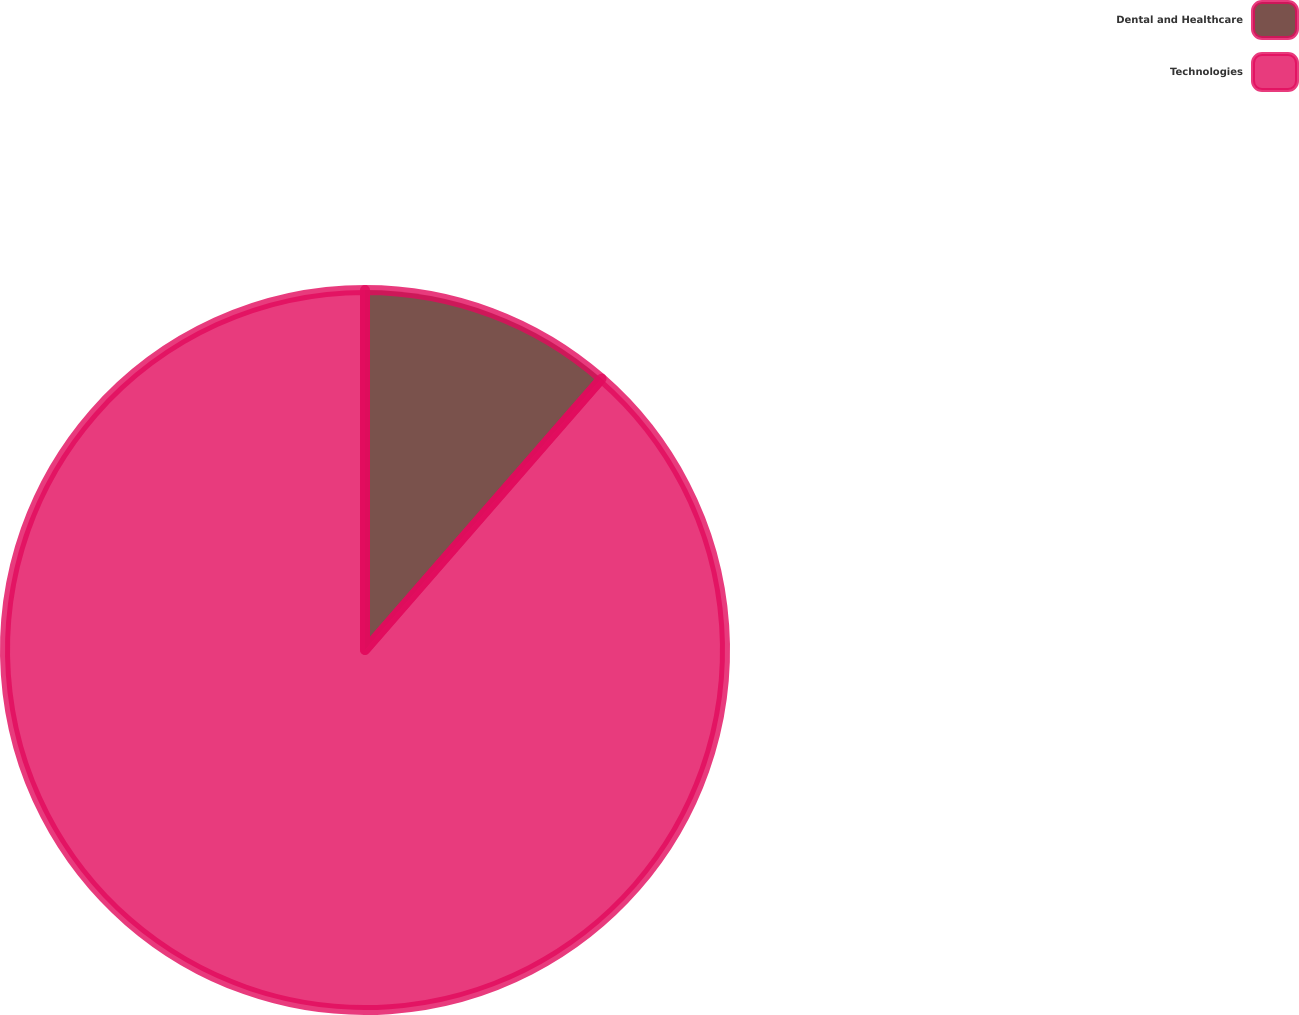Convert chart to OTSL. <chart><loc_0><loc_0><loc_500><loc_500><pie_chart><fcel>Dental and Healthcare<fcel>Technologies<nl><fcel>11.41%<fcel>88.59%<nl></chart> 